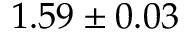Convert formula to latex. <formula><loc_0><loc_0><loc_500><loc_500>1 . 5 9 \pm 0 . 0 3</formula> 